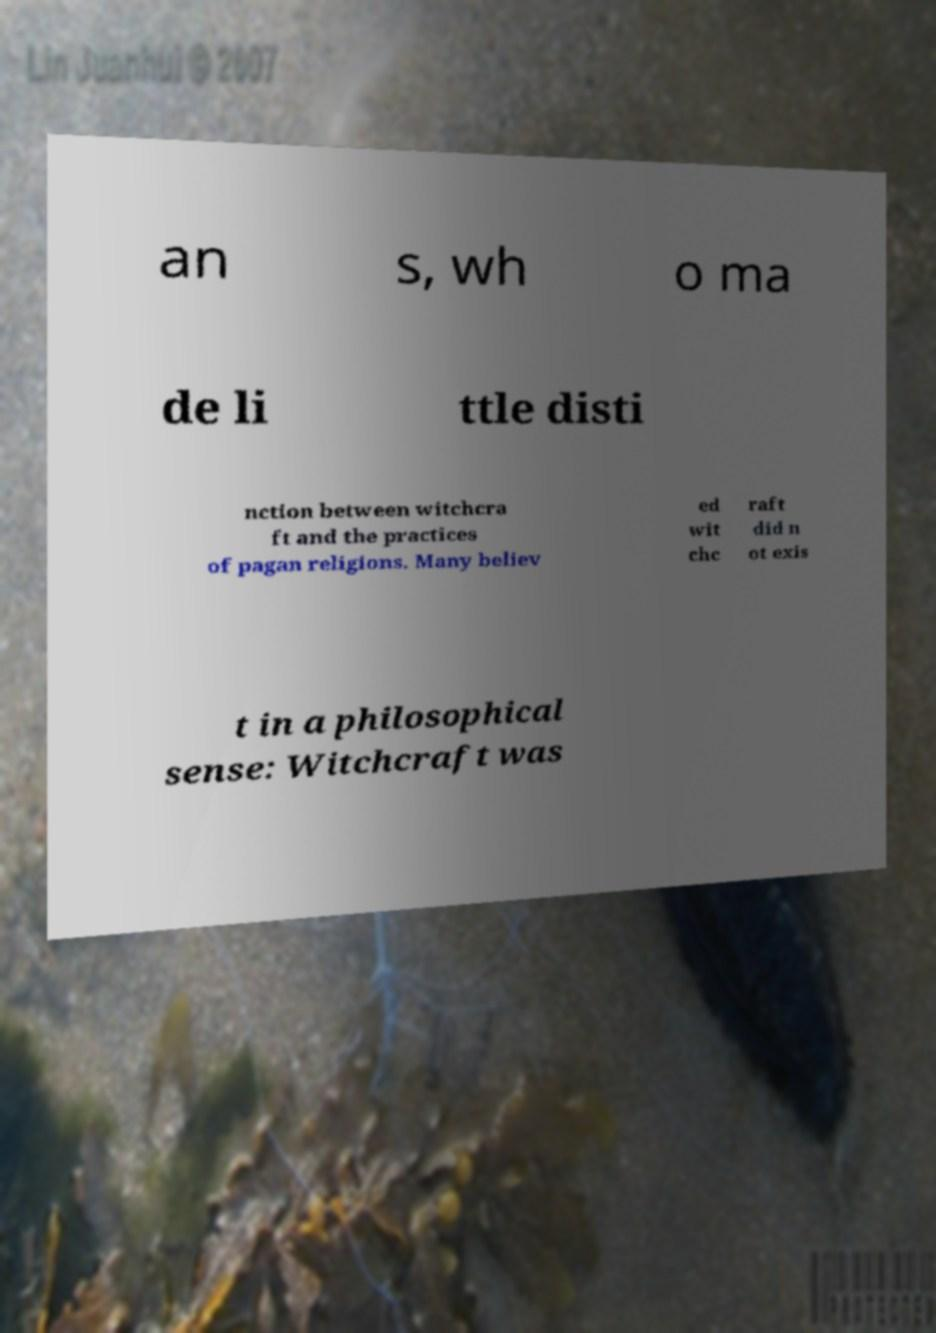I need the written content from this picture converted into text. Can you do that? an s, wh o ma de li ttle disti nction between witchcra ft and the practices of pagan religions. Many believ ed wit chc raft did n ot exis t in a philosophical sense: Witchcraft was 